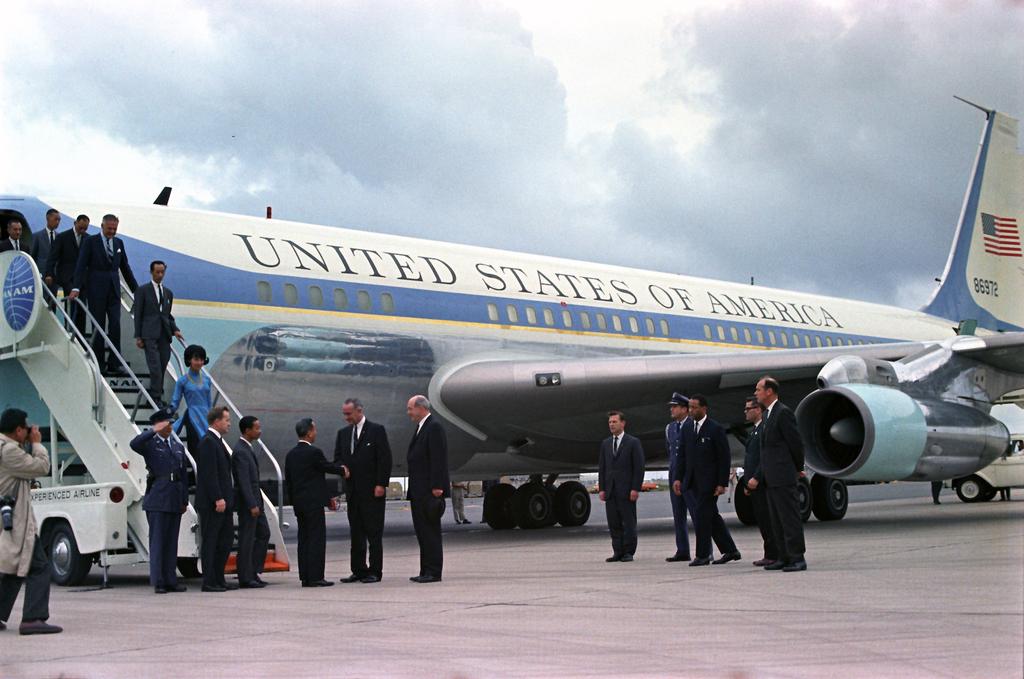What country does this jet liner belong to?
Offer a terse response. United states of america. What are the numbers on the tail of the airplane?
Give a very brief answer. 86972. 